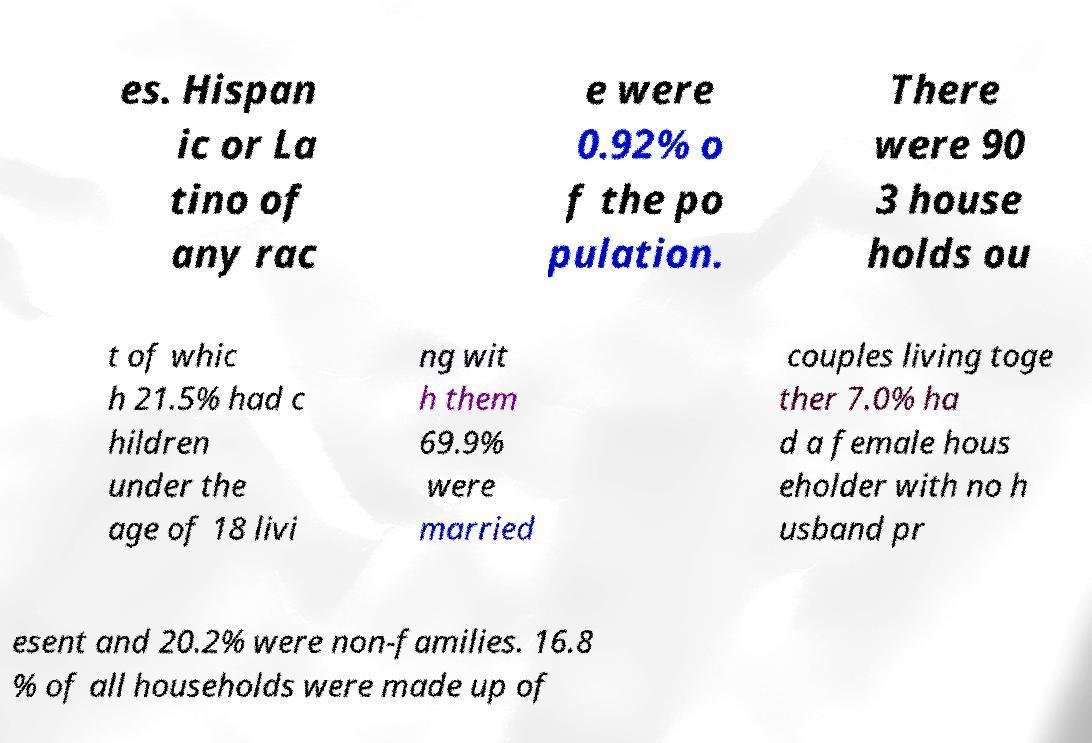Could you assist in decoding the text presented in this image and type it out clearly? es. Hispan ic or La tino of any rac e were 0.92% o f the po pulation. There were 90 3 house holds ou t of whic h 21.5% had c hildren under the age of 18 livi ng wit h them 69.9% were married couples living toge ther 7.0% ha d a female hous eholder with no h usband pr esent and 20.2% were non-families. 16.8 % of all households were made up of 